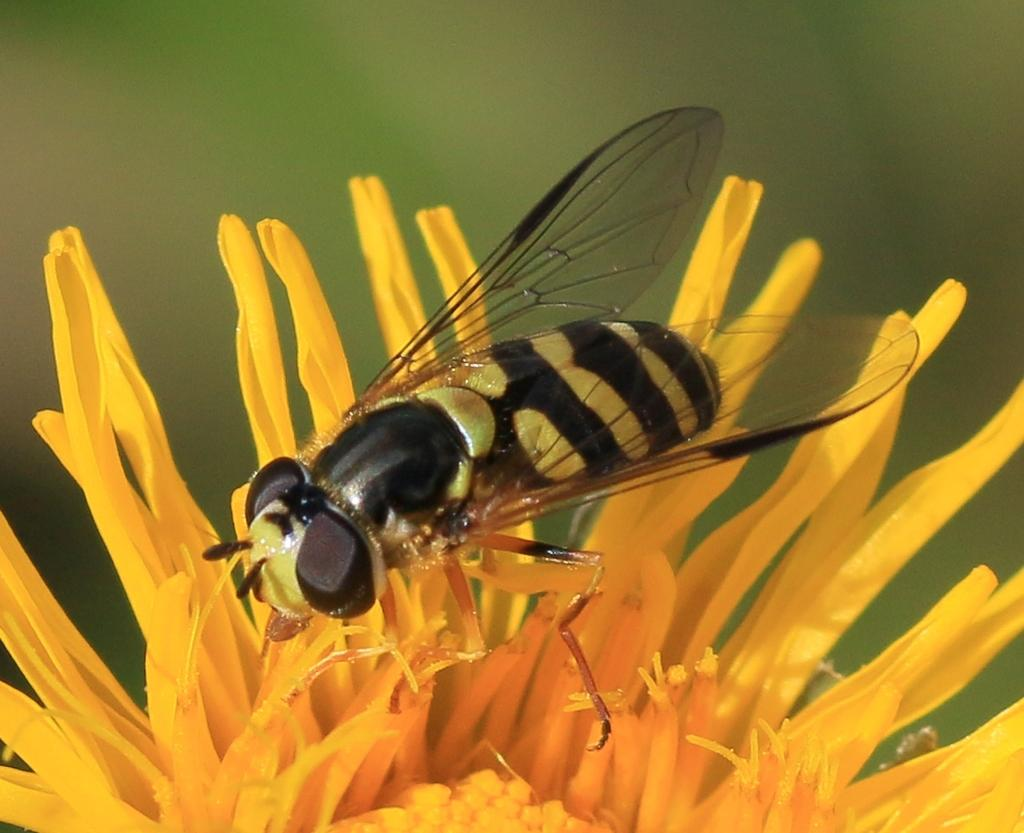What is the main subject of the image? The main subject of the image is a bee. Where is the bee located in the image? The bee is on a flower. Can you describe the background of the image? The background of the image is blurry. What type of roll is the bee using to fly in the image? There is no roll present in the image, and the bee is not using any roll to fly. Who is the minister in the image? There is no minister present in the image. --- Facts: 1. There is a car in the image. 2. The car is parked on the street. 3. There are buildings in the background of the image. 4. The street is visible in the image. Absurd Topics: ocean, dolphin, waves Conversation: What is the main subject of the image? The main subject of the image is a car. Where is the car located in the image? The car is parked on the street. What can be seen in the background of the image? There are buildings in the background of the image. What is visible on the ground in the image? The street is visible in the image. Reasoning: Let's think step by step in order to produce the conversation. We start by identifying the main subject of the image, which is the car. Next, we describe the location of the car, which is parked on the street. Then, we describe the background of the image, which includes buildings. Finally, we describe the ground in the image, which is the street. Absurd Question/Answer: What type of ocean waves can be seen crashing against the car in the image? There is no ocean or waves present in the image; it features a car parked on the street with buildings in the background. 